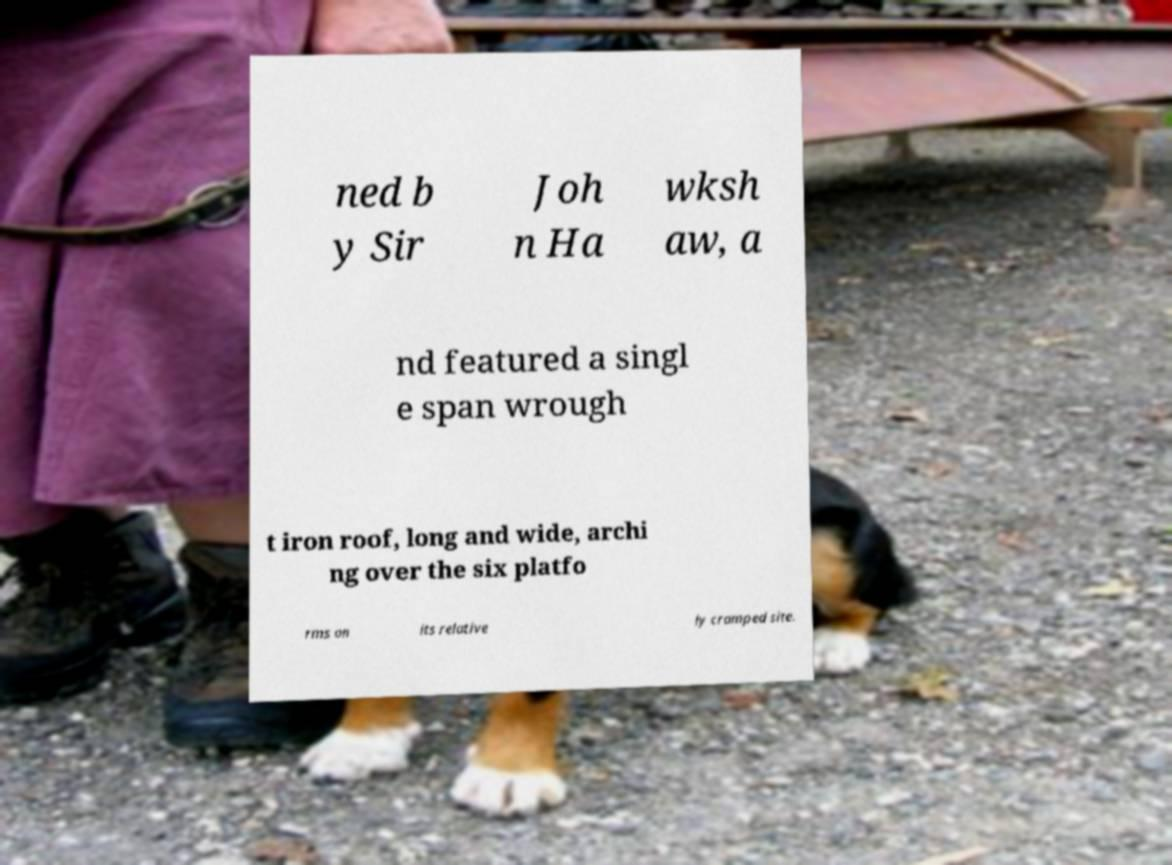I need the written content from this picture converted into text. Can you do that? ned b y Sir Joh n Ha wksh aw, a nd featured a singl e span wrough t iron roof, long and wide, archi ng over the six platfo rms on its relative ly cramped site. 